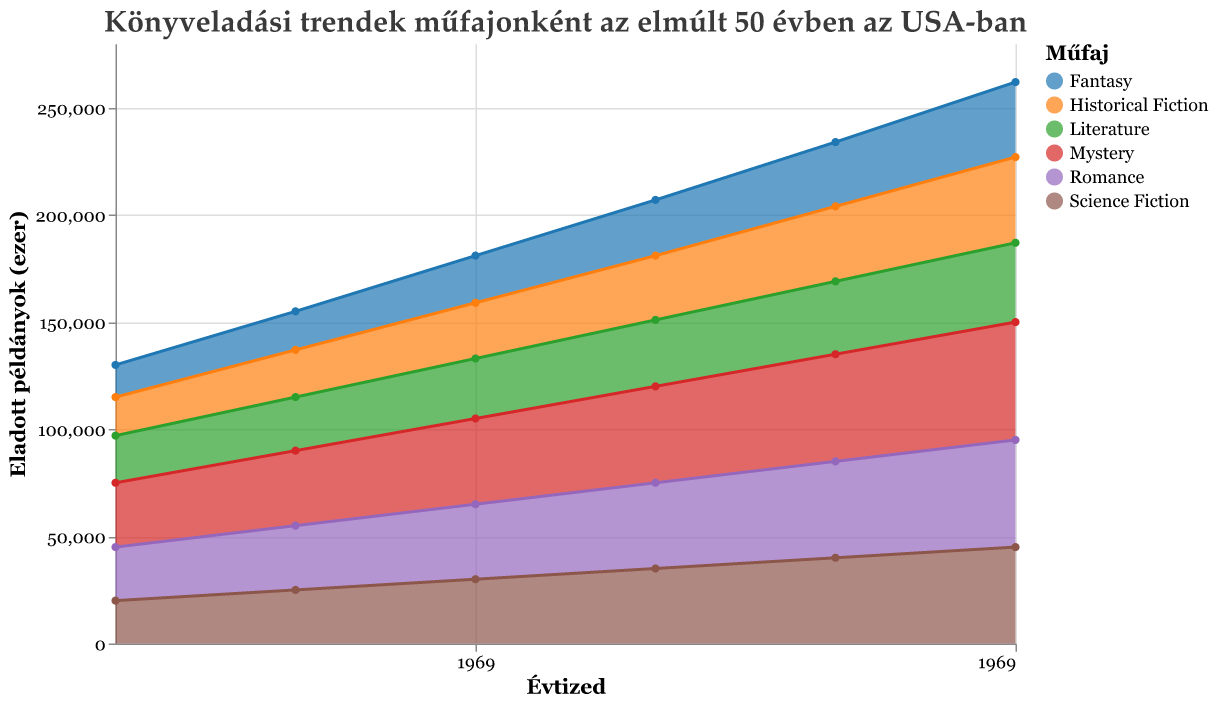What is the title of the figure? The title of the figure is displayed prominently at the top and is written in Hungarian. It indicates the theme of the chart, which relates to book sales trends by genre over the last 50 years in the US.
Answer: Könyveladási trendek műfajonként az elmúlt 50 évben az USA-ban Which genre had the highest book sales in 2020? By looking at the area chart for the year 2020, we can identify the genre with the highest sales value. The area representing Mystery is the highest compared to other genres in 2020.
Answer: Mystery How many genres are being tracked in this chart? The legend to the right categorizes the different genres being tracked. Counting the entries in the legend, we find there are six genres represented.
Answer: Six What was the trend in Science Fiction book sales between 1970 and 2020? To discern the trend for Science Fiction, look at the Science Fiction area on the chart. The area increases steadily from 1970 to 2020, indicating a continuous rise in book sales.
Answer: Increasing What was the approximate difference in Mystery book sales between 1970 and 2020? Compare the values of Mystery sales in 1970 and 2020. In 1970, Mystery sales were 30,000, and in 2020, they were 55,000. Subtracting these gives the difference: 55,000 - 30,000.
Answer: 25,000 Which genre had the lowest book sales in 1980? For the year 1980, look at the smallest area on the chart. The Fantasy area is the smallest in 1980, indicating it had the lowest sales.
Answer: Fantasy How did the total book sales for all genres combined change from 1970 to 2020? To find this, sum the sales of all genres for the respective years. In 1970: 20,000 + 15,000 + 30,000 + 25,000 + 18,000 + 22,000 = 130,000; in 2020: 45,000 + 35,000 + 55,000 + 50,000 + 40,000 + 37,000 = 262,000. The change is 262,000 - 130,000.
Answer: 132,000 Which genre showed the most significant growth over the 50-year period? To determine significant growth, compare the increase in sales for each genre from 1970 to 2020. Mystery sales grew from 30,000 to 55,000, the highest absolute growth of 25,000.
Answer: Mystery What pattern can be seen in Romance book sales from 1970 to 2020? Observing the Romance area on the chart, it consistently increases in each decade up to 2020.
Answer: Continuously increasing Which genres have sales that increased by exactly 5,000 units each decade? Analyze the genres decade by decade. Science Fiction shows an increase of 5,000 each decade from 1970 (20,000) to 2020 (45,000).
Answer: Science Fiction 